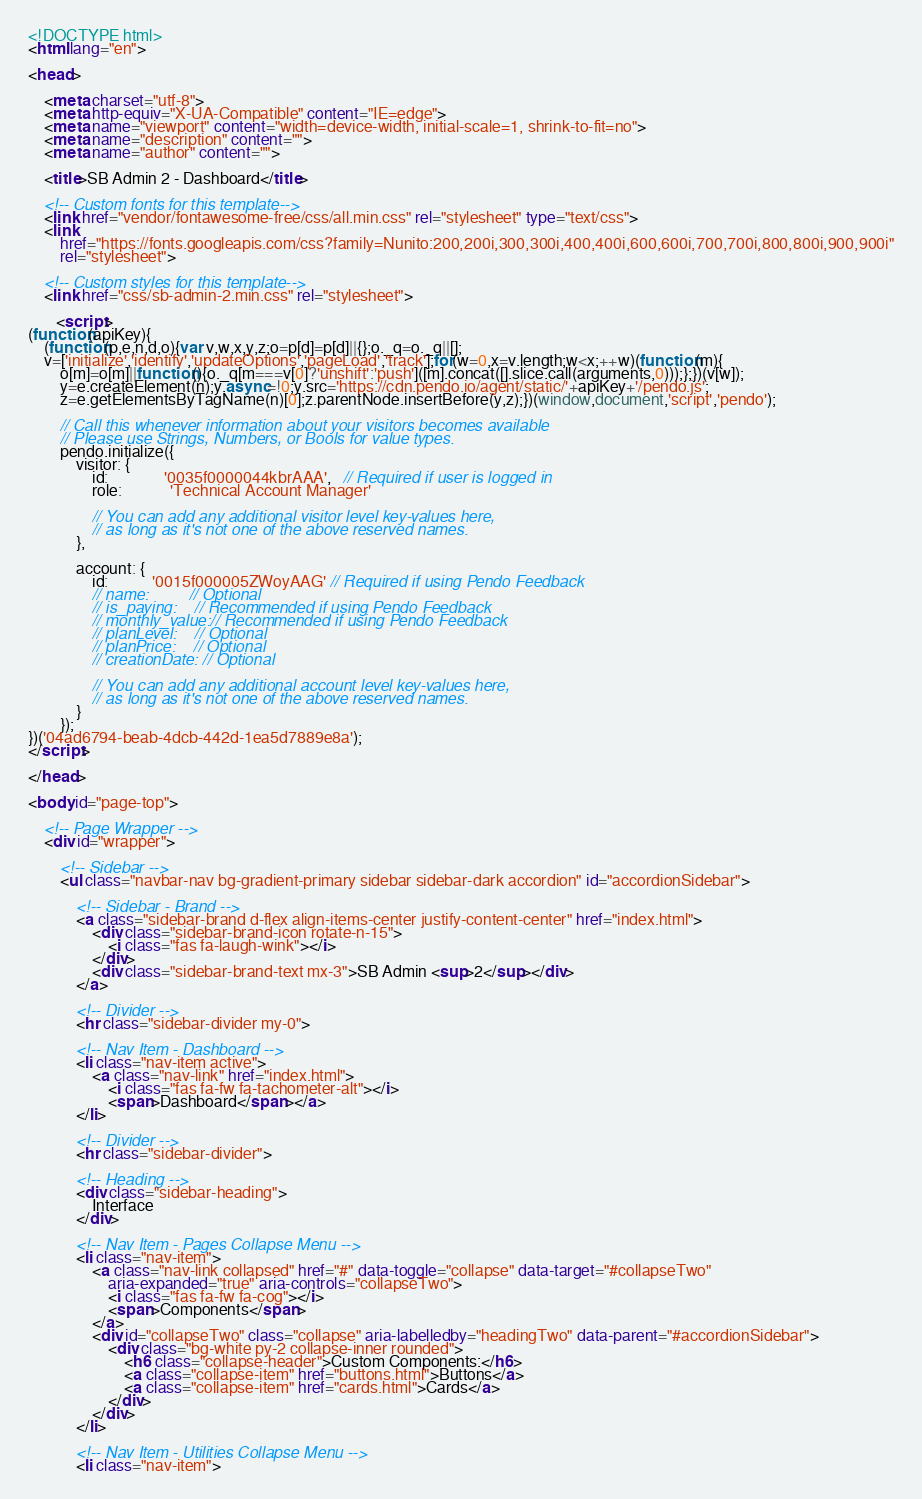<code> <loc_0><loc_0><loc_500><loc_500><_HTML_><!DOCTYPE html>
<html lang="en">

<head>

    <meta charset="utf-8">
    <meta http-equiv="X-UA-Compatible" content="IE=edge">
    <meta name="viewport" content="width=device-width, initial-scale=1, shrink-to-fit=no">
    <meta name="description" content="">
    <meta name="author" content="">

    <title>SB Admin 2 - Dashboard</title>

    <!-- Custom fonts for this template-->
    <link href="vendor/fontawesome-free/css/all.min.css" rel="stylesheet" type="text/css">
    <link
        href="https://fonts.googleapis.com/css?family=Nunito:200,200i,300,300i,400,400i,600,600i,700,700i,800,800i,900,900i"
        rel="stylesheet">

    <!-- Custom styles for this template-->
    <link href="css/sb-admin-2.min.css" rel="stylesheet">
    
       <script>
(function(apiKey){
    (function(p,e,n,d,o){var v,w,x,y,z;o=p[d]=p[d]||{};o._q=o._q||[];
    v=['initialize','identify','updateOptions','pageLoad','track'];for(w=0,x=v.length;w<x;++w)(function(m){
        o[m]=o[m]||function(){o._q[m===v[0]?'unshift':'push']([m].concat([].slice.call(arguments,0)));};})(v[w]);
        y=e.createElement(n);y.async=!0;y.src='https://cdn.pendo.io/agent/static/'+apiKey+'/pendo.js';
        z=e.getElementsByTagName(n)[0];z.parentNode.insertBefore(y,z);})(window,document,'script','pendo');

        // Call this whenever information about your visitors becomes available
        // Please use Strings, Numbers, or Bools for value types.
        pendo.initialize({
            visitor: {
                id:              '0035f0000044kbrAAA',   // Required if user is logged in
                role:            'Technical Account Manager' 

                // You can add any additional visitor level key-values here,
                // as long as it's not one of the above reserved names.
            },

            account: {
                id:           '0015f000005ZWoyAAG' // Required if using Pendo Feedback
                // name:         // Optional
                // is_paying:    // Recommended if using Pendo Feedback
                // monthly_value:// Recommended if using Pendo Feedback
                // planLevel:    // Optional
                // planPrice:    // Optional
                // creationDate: // Optional

                // You can add any additional account level key-values here,
                // as long as it's not one of the above reserved names.
            }
        });
})('04ad6794-beab-4dcb-442d-1ea5d7889e8a');
</script>
    
</head>

<body id="page-top">

    <!-- Page Wrapper -->
    <div id="wrapper">

        <!-- Sidebar -->
        <ul class="navbar-nav bg-gradient-primary sidebar sidebar-dark accordion" id="accordionSidebar">

            <!-- Sidebar - Brand -->
            <a class="sidebar-brand d-flex align-items-center justify-content-center" href="index.html">
                <div class="sidebar-brand-icon rotate-n-15">
                    <i class="fas fa-laugh-wink"></i>
                </div>
                <div class="sidebar-brand-text mx-3">SB Admin <sup>2</sup></div>
            </a>

            <!-- Divider -->
            <hr class="sidebar-divider my-0">

            <!-- Nav Item - Dashboard -->
            <li class="nav-item active">
                <a class="nav-link" href="index.html">
                    <i class="fas fa-fw fa-tachometer-alt"></i>
                    <span>Dashboard</span></a>
            </li>

            <!-- Divider -->
            <hr class="sidebar-divider">

            <!-- Heading -->
            <div class="sidebar-heading">
                Interface
            </div>

            <!-- Nav Item - Pages Collapse Menu -->
            <li class="nav-item">
                <a class="nav-link collapsed" href="#" data-toggle="collapse" data-target="#collapseTwo"
                    aria-expanded="true" aria-controls="collapseTwo">
                    <i class="fas fa-fw fa-cog"></i>
                    <span>Components</span>
                </a>
                <div id="collapseTwo" class="collapse" aria-labelledby="headingTwo" data-parent="#accordionSidebar">
                    <div class="bg-white py-2 collapse-inner rounded">
                        <h6 class="collapse-header">Custom Components:</h6>
                        <a class="collapse-item" href="buttons.html">Buttons</a>
                        <a class="collapse-item" href="cards.html">Cards</a>
                    </div>
                </div>
            </li>

            <!-- Nav Item - Utilities Collapse Menu -->
            <li class="nav-item"></code> 